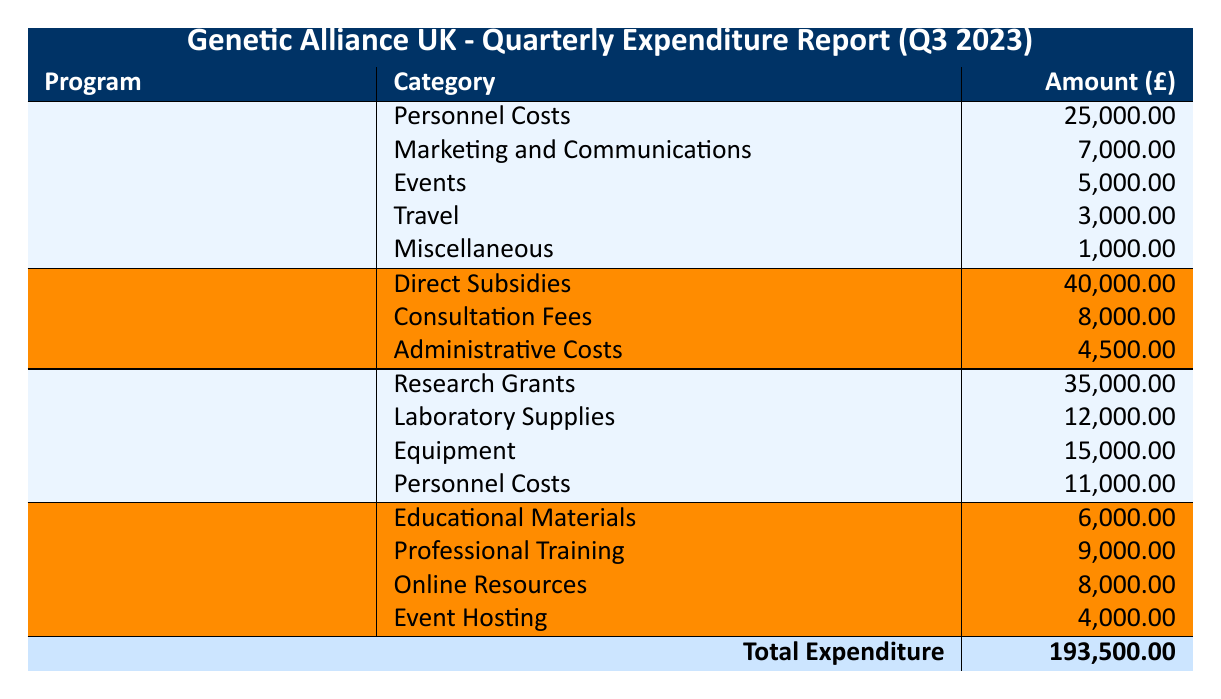What is the total expenditure for the Genetic Disorder Awareness Campaign? The total amount for the Genetic Disorder Awareness Campaign can be calculated by summing the amounts of each category listed: 25,000 + 7,000 + 5,000 + 3,000 + 1,000 = 41,000.
Answer: 41,000 How much was spent on Personnel Costs across all programs? The expenditure on Personnel Costs is the sum of all related entries: 25,000 (Genetic Disorder Awareness Campaign) + 11,000 (Research Collaboration Projects) = 36,000.
Answer: 36,000 Did the Genetic Testing Subsidy Initiative have any Marketing and Communications expenses? The Genetic Testing Subsidy Initiative does not list Marketing and Communications as a category; hence, there were no related expenses.
Answer: No What category had the highest expenditure in the Research Collaboration Projects? The amounts for each category in the Research Collaboration Projects are: Research Grants 35,000, Laboratory Supplies 12,000, Equipment 15,000, and Personnel Costs 11,000. The highest amount is 35,000 for Research Grants.
Answer: Research Grants What is the average expenditure of the Public Health Education on Genetic Conditions program across its categories? The total expenditure for the Public Health Education on Genetic Conditions program is 6,000 + 9,000 + 8,000 + 4,000 = 27,000. There are four categories, so the average is 27,000 / 4 = 6,750.
Answer: 6,750 Is the total amount spent on the Genetic Testing Subsidy Initiative higher than the Genetic Disorder Awareness Campaign? The total amount for the Genetic Testing Subsidy Initiative is 40,000 + 8,000 + 4,500 = 52,500, while the Genetic Disorder Awareness Campaign totals 41,000. Since 52,500 is greater than 41,000, the statement is true.
Answer: Yes What is the difference in expenditure between the highest and lowest program total? The highest total program expenditure is for the Genetic Testing Subsidy Initiative at 52,500 and the lowest is the Genetic Disorder Awareness Campaign at 41,000. The difference is 52,500 - 41,000 = 11,500.
Answer: 11,500 How much more was spent on Direct Subsidies compared to Administrative Costs within the Genetic Testing Subsidy Initiative? Direct Subsidies amount to 40,000 and Administrative Costs amount to 4,500. The difference is 40,000 - 4,500 = 35,500.
Answer: 35,500 How many different expenditure categories are listed under the Public Health Education on Genetic Conditions program? There are four categories listed for this program: Educational Materials, Professional Training, Online Resources, and Event Hosting.
Answer: 4 